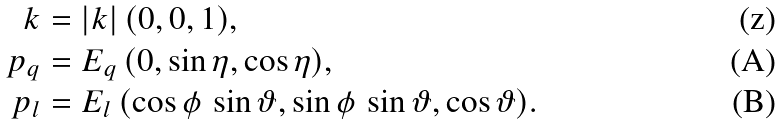Convert formula to latex. <formula><loc_0><loc_0><loc_500><loc_500>k & = | k | \, ( 0 , 0 , 1 ) , \\ p _ { q } & = E _ { q } \, ( 0 , \sin \eta , \cos \eta ) , \\ p _ { l } & = E _ { l } \, ( \cos \phi \, \sin \vartheta , \sin \phi \, \sin \vartheta , \cos \vartheta ) .</formula> 